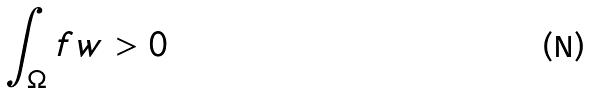<formula> <loc_0><loc_0><loc_500><loc_500>\int _ { \Omega } f w > 0</formula> 